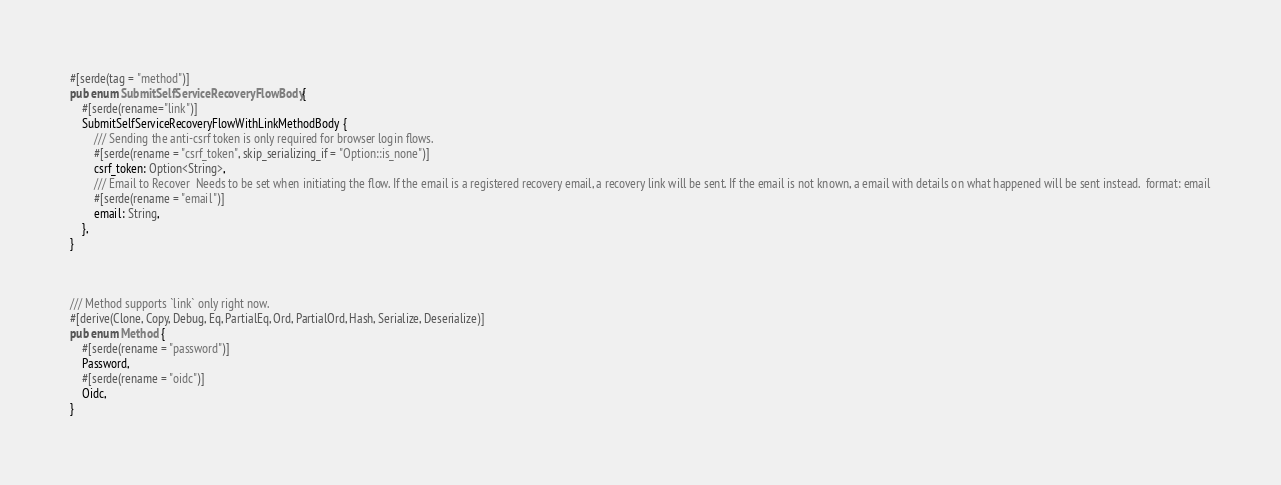<code> <loc_0><loc_0><loc_500><loc_500><_Rust_>#[serde(tag = "method")]
pub enum SubmitSelfServiceRecoveryFlowBody {
    #[serde(rename="link")]
    SubmitSelfServiceRecoveryFlowWithLinkMethodBody {
        /// Sending the anti-csrf token is only required for browser login flows.
        #[serde(rename = "csrf_token", skip_serializing_if = "Option::is_none")]
        csrf_token: Option<String>,
        /// Email to Recover  Needs to be set when initiating the flow. If the email is a registered recovery email, a recovery link will be sent. If the email is not known, a email with details on what happened will be sent instead.  format: email
        #[serde(rename = "email")]
        email: String,
    },
}



/// Method supports `link` only right now.
#[derive(Clone, Copy, Debug, Eq, PartialEq, Ord, PartialOrd, Hash, Serialize, Deserialize)]
pub enum Method {
    #[serde(rename = "password")]
    Password,
    #[serde(rename = "oidc")]
    Oidc,
}

</code> 